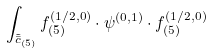<formula> <loc_0><loc_0><loc_500><loc_500>\int _ { \tilde { \bar { c } } _ { ( \bar { 5 } ) } } f _ { ( \bar { 5 } ) } ^ { ( 1 / 2 , 0 ) } \cdot \psi ^ { ( 0 , 1 ) } \cdot f _ { ( { 5 } ) } ^ { ( 1 / 2 , 0 ) }</formula> 